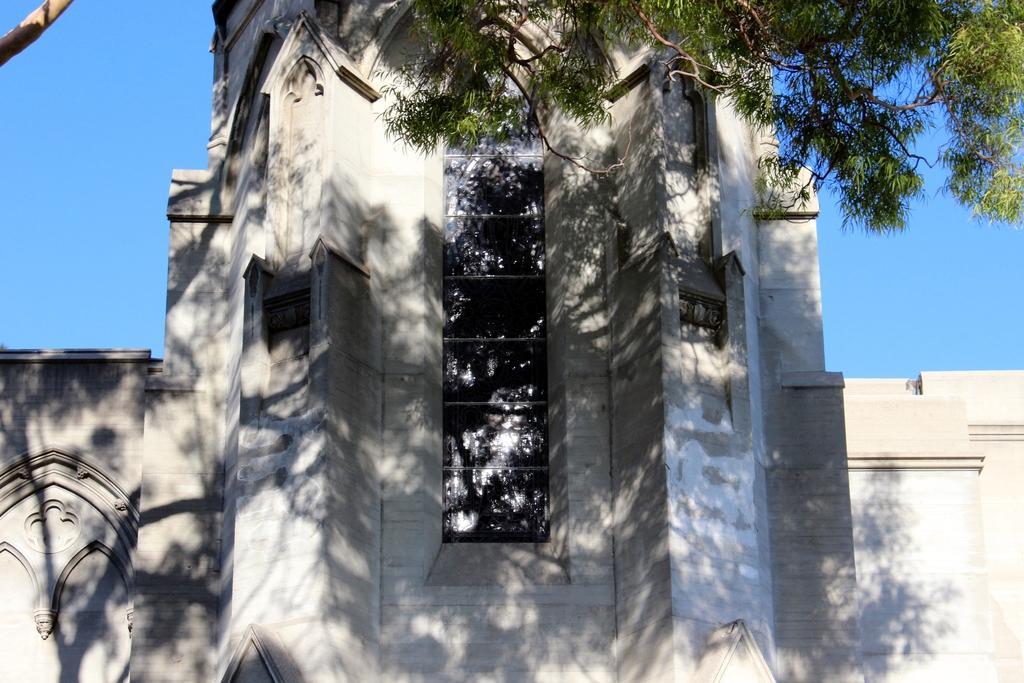Describe this image in one or two sentences. As we can see in the image there is a white color car and tree. On the top there is blue sky. 